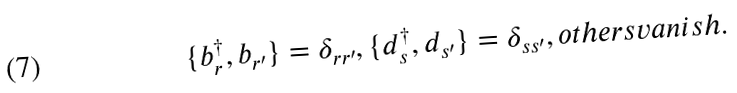<formula> <loc_0><loc_0><loc_500><loc_500>\{ b ^ { \dagger } _ { r } , b _ { r ^ { \prime } } \} = \delta _ { r r ^ { \prime } } , \{ d ^ { \dagger } _ { s } , d _ { s ^ { \prime } } \} = \delta _ { s s ^ { \prime } } , o t h e r s v a n i s h .</formula> 